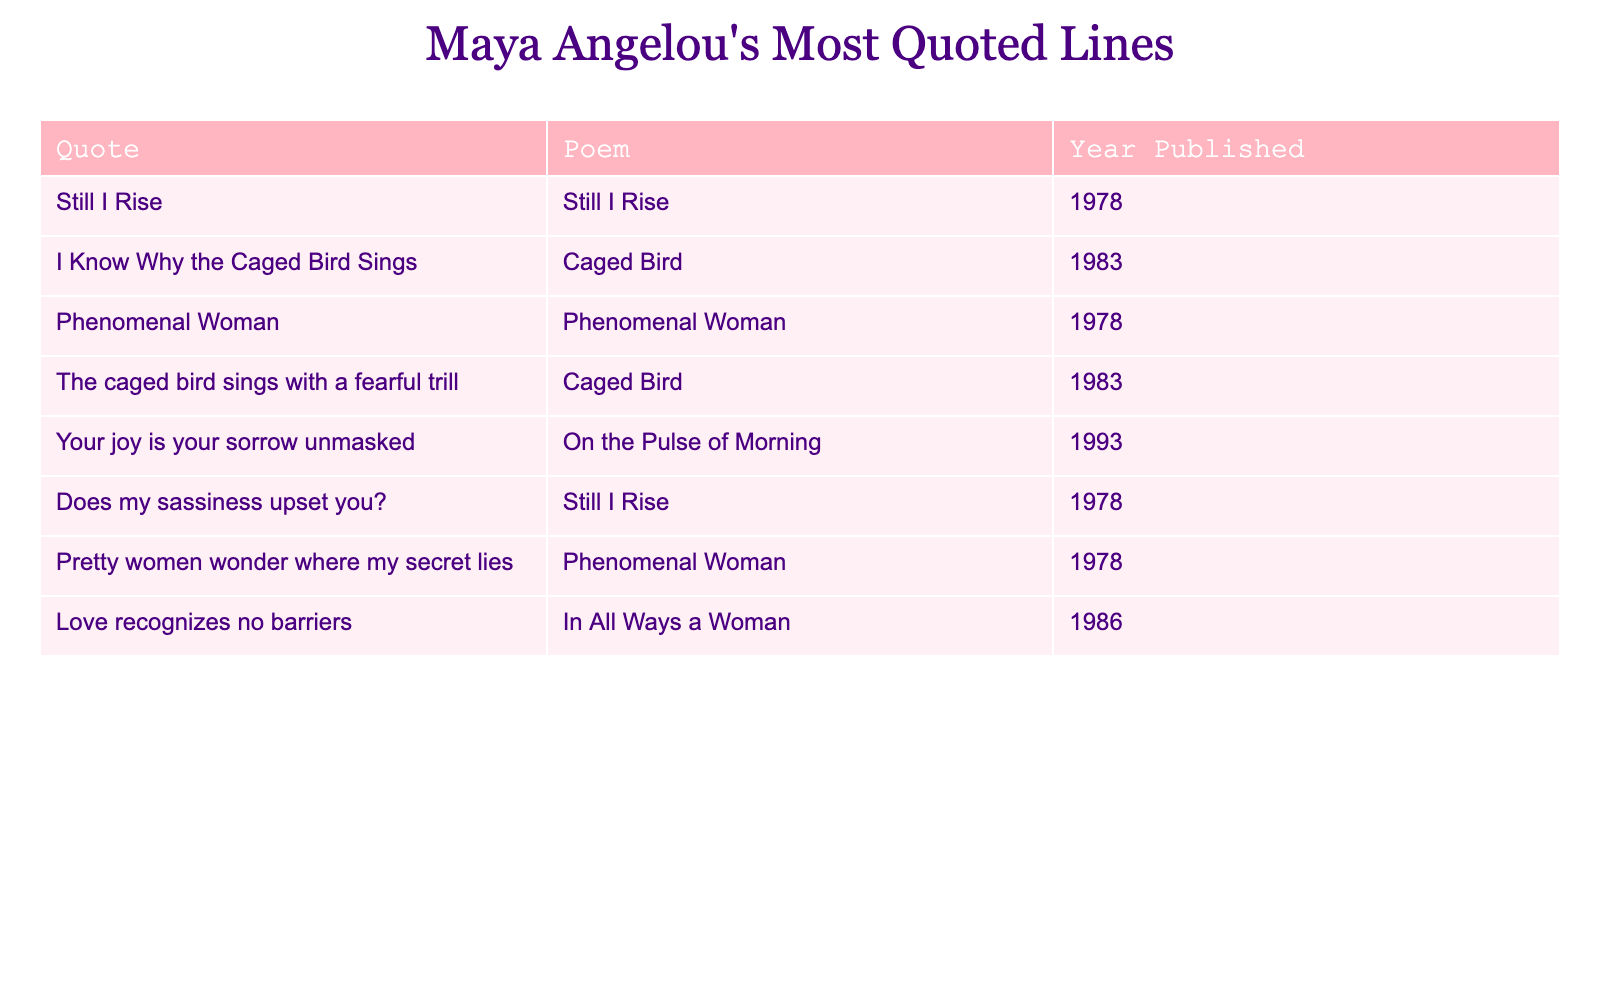What is the most frequently quoted line from Maya Angelou's poems? The line "Still I Rise" appears twice in the table, making it the most frequently quoted line.
Answer: "Still I Rise" Which poem was published in 1978 that contains a line about a "caged bird"? The poem "Caged Bird" was published in 1983 and it contains the line "The caged bird sings with a fearful trill". Therefore, there is no line from a 1978 poem that refers to a "caged bird".
Answer: No How many poems have been quoted in the table? There are 6 unique poems mentioned in the table: "Still I Rise," "Caged Bird," "Phenomenal Woman," "On the Pulse of Morning," and "In All Ways a Woman." Counting distinct titles gives us 6.
Answer: 6 What is the year of publication for the line "Your joy is your sorrow unmasked"? This line is from the poem "On the Pulse of Morning", which was published in 1993.
Answer: 1993 How many lines are quoted from the poem "Still I Rise"? There are 2 lines quoted from "Still I Rise": "Still I Rise" and "Does my sassiness upset you?".
Answer: 2 Which poem has the line "Pretty women wonder where my secret lies" and when was it published? This line is from "Phenomenal Woman", published in 1978.
Answer: "Phenomenal Woman", 1978 What is the average publication year of the poems quoted in the table? The publication years are 1978 (3 poems), 1983 (2 poems), 1993, and 1986. Calculating the average of these years: (1978 + 1983 + 1978 + 1983 + 1993 + 1986) / 6 = 1980.33. Rounding gives an average year of 1980.
Answer: 1980 Is there any quote from the poem "In All Ways a Woman"? Yes, the line "Love recognizes no barriers" is from the poem "In All Ways a Woman".
Answer: Yes How many lines were quoted from poems published after 1980? The poems published after 1980 are "On the Pulse of Morning" (1993) and "In All Ways a Woman" (1986), with 2 lines quoted from these poems total.
Answer: 2 From which year is the earliest quoted line in the table? The earliest year listed in the table is 1978, corresponding to multiple lines including "Still I Rise".
Answer: 1978 